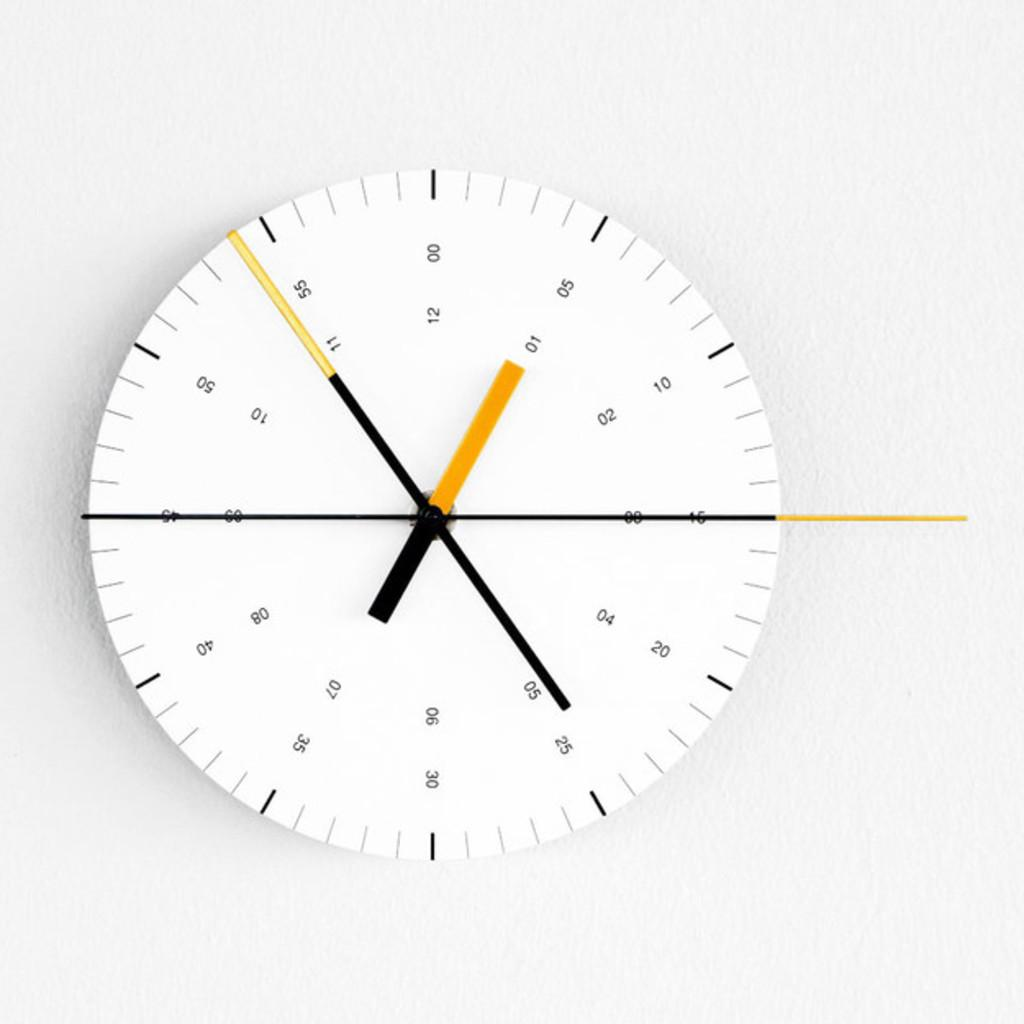<image>
Create a compact narrative representing the image presented. A clock with small numbers is showing the time 12:54. 